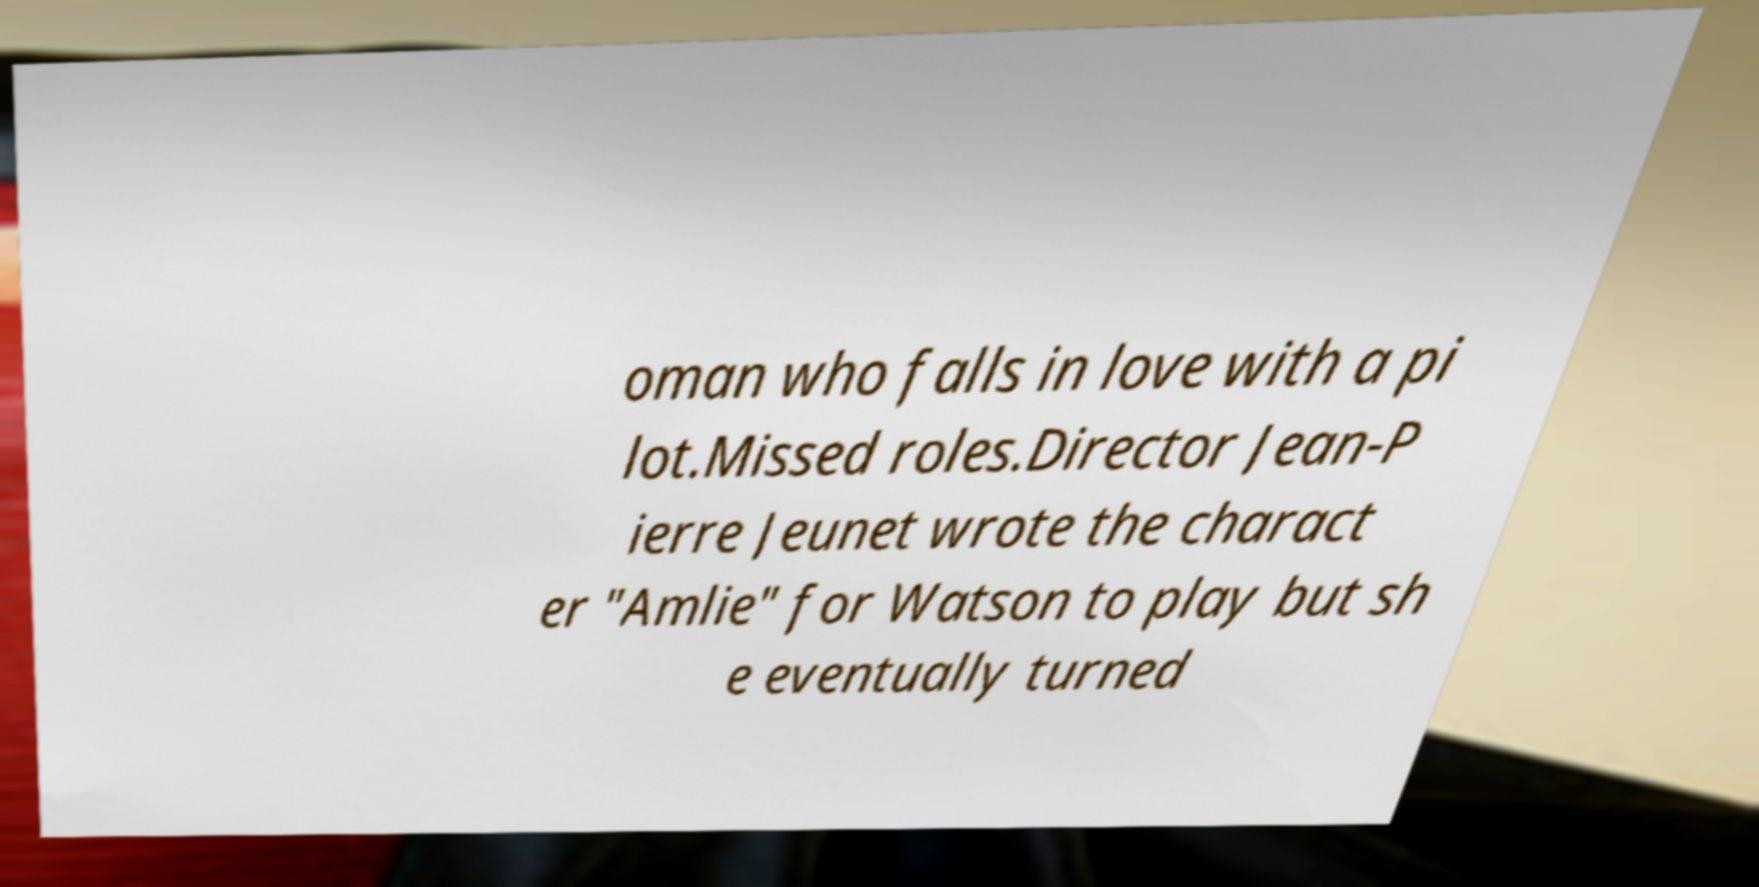Please identify and transcribe the text found in this image. oman who falls in love with a pi lot.Missed roles.Director Jean-P ierre Jeunet wrote the charact er "Amlie" for Watson to play but sh e eventually turned 